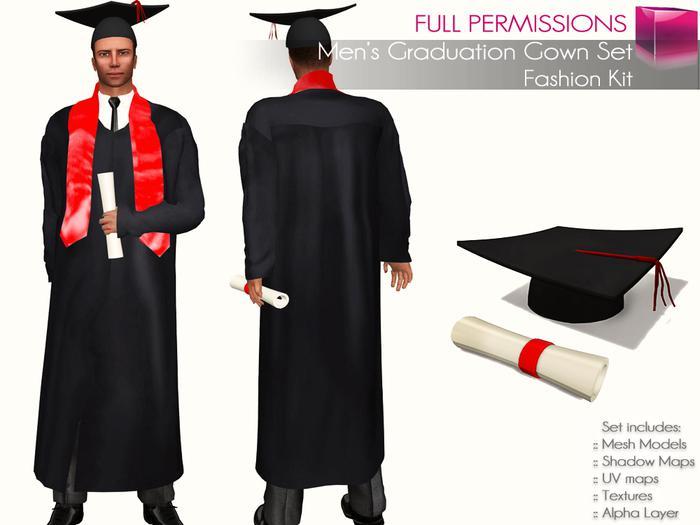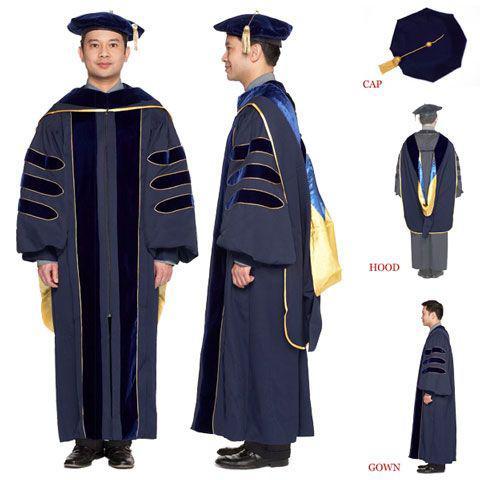The first image is the image on the left, the second image is the image on the right. For the images shown, is this caption "A graduation gown option includes a short red scarf that stops at the waist." true? Answer yes or no. Yes. The first image is the image on the left, the second image is the image on the right. Given the left and right images, does the statement "There is a woman in the image on the right." hold true? Answer yes or no. No. 